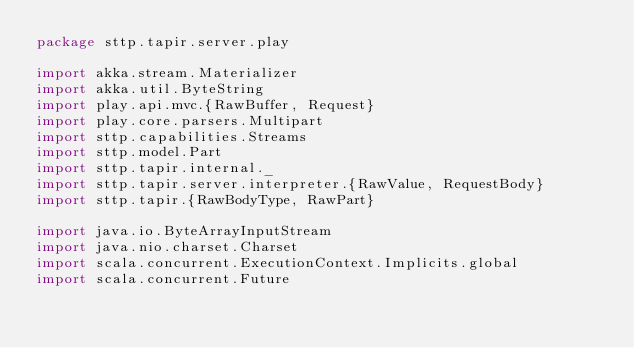<code> <loc_0><loc_0><loc_500><loc_500><_Scala_>package sttp.tapir.server.play

import akka.stream.Materializer
import akka.util.ByteString
import play.api.mvc.{RawBuffer, Request}
import play.core.parsers.Multipart
import sttp.capabilities.Streams
import sttp.model.Part
import sttp.tapir.internal._
import sttp.tapir.server.interpreter.{RawValue, RequestBody}
import sttp.tapir.{RawBodyType, RawPart}

import java.io.ByteArrayInputStream
import java.nio.charset.Charset
import scala.concurrent.ExecutionContext.Implicits.global
import scala.concurrent.Future
</code> 